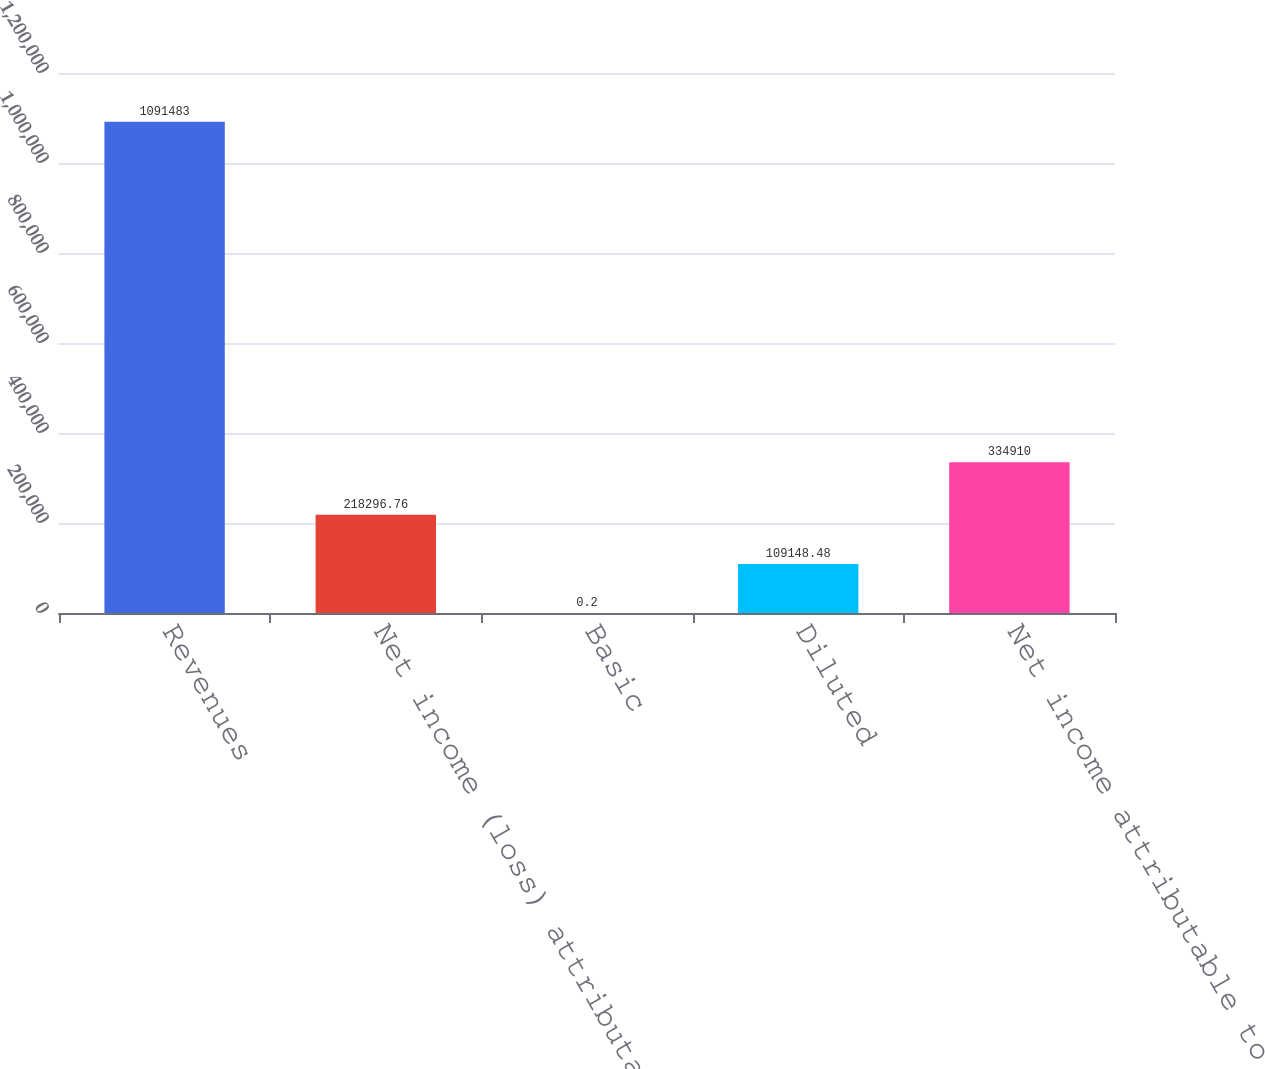<chart> <loc_0><loc_0><loc_500><loc_500><bar_chart><fcel>Revenues<fcel>Net income (loss) attributable<fcel>Basic<fcel>Diluted<fcel>Net income attributable to<nl><fcel>1.09148e+06<fcel>218297<fcel>0.2<fcel>109148<fcel>334910<nl></chart> 